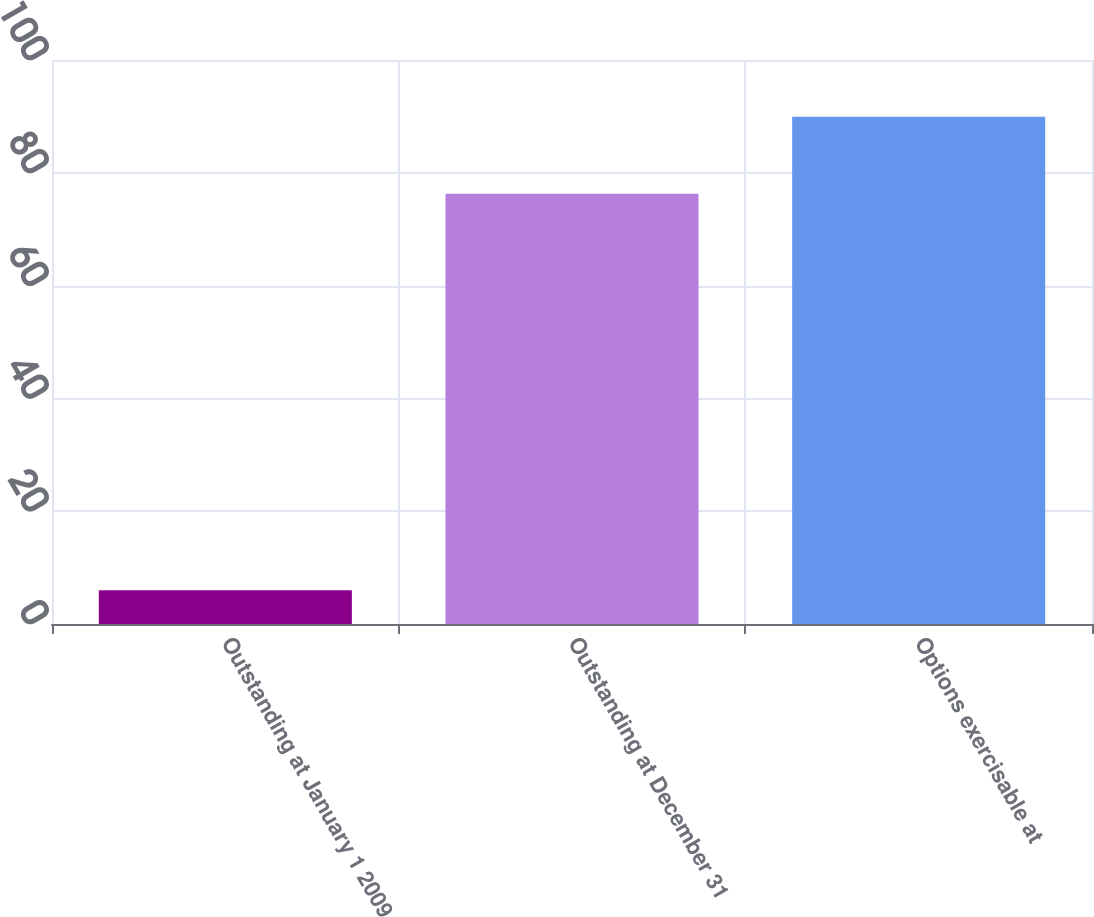Convert chart. <chart><loc_0><loc_0><loc_500><loc_500><bar_chart><fcel>Outstanding at January 1 2009<fcel>Outstanding at December 31<fcel>Options exercisable at<nl><fcel>6<fcel>76.3<fcel>89.92<nl></chart> 